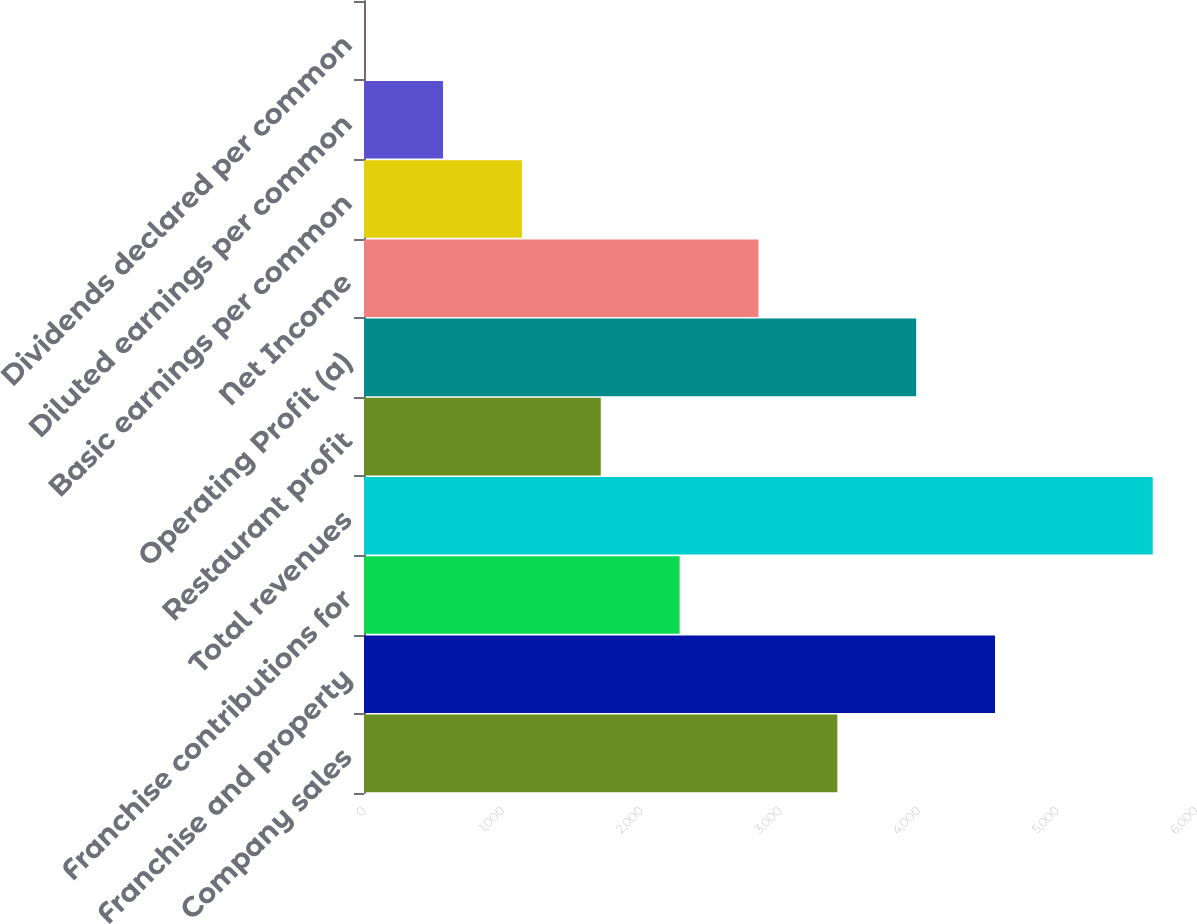<chart> <loc_0><loc_0><loc_500><loc_500><bar_chart><fcel>Company sales<fcel>Franchise and property<fcel>Franchise contributions for<fcel>Total revenues<fcel>Restaurant profit<fcel>Operating Profit (a)<fcel>Net Income<fcel>Basic earnings per common<fcel>Diluted earnings per common<fcel>Dividends declared per common<nl><fcel>3413.4<fcel>4550.72<fcel>2276.08<fcel>5688<fcel>1707.42<fcel>3982.06<fcel>2844.74<fcel>1138.76<fcel>570.1<fcel>1.44<nl></chart> 